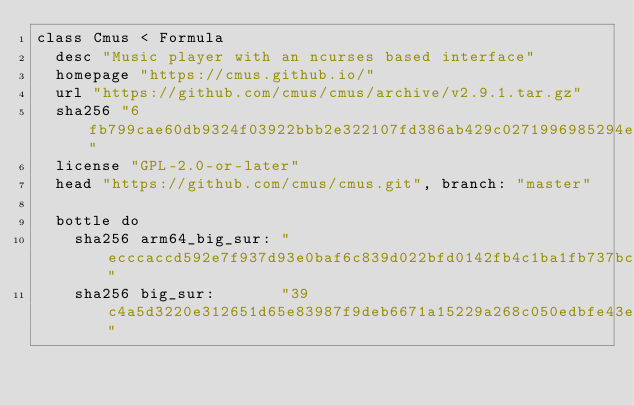Convert code to text. <code><loc_0><loc_0><loc_500><loc_500><_Ruby_>class Cmus < Formula
  desc "Music player with an ncurses based interface"
  homepage "https://cmus.github.io/"
  url "https://github.com/cmus/cmus/archive/v2.9.1.tar.gz"
  sha256 "6fb799cae60db9324f03922bbb2e322107fd386ab429c0271996985294e2ef44"
  license "GPL-2.0-or-later"
  head "https://github.com/cmus/cmus.git", branch: "master"

  bottle do
    sha256 arm64_big_sur: "ecccaccd592e7f937d93e0baf6c839d022bfd0142fb4c1ba1fb737bc5320cb8d"
    sha256 big_sur:       "39c4a5d3220e312651d65e83987f9deb6671a15229a268c050edbfe43ea259b2"</code> 